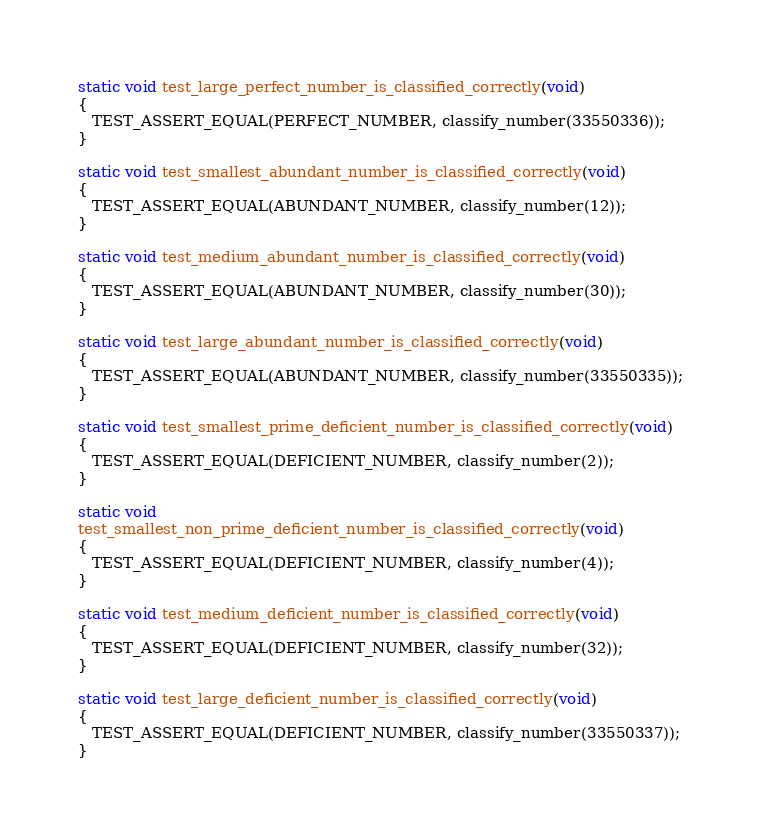<code> <loc_0><loc_0><loc_500><loc_500><_C_>static void test_large_perfect_number_is_classified_correctly(void)
{
   TEST_ASSERT_EQUAL(PERFECT_NUMBER, classify_number(33550336));
}

static void test_smallest_abundant_number_is_classified_correctly(void)
{
   TEST_ASSERT_EQUAL(ABUNDANT_NUMBER, classify_number(12));
}

static void test_medium_abundant_number_is_classified_correctly(void)
{
   TEST_ASSERT_EQUAL(ABUNDANT_NUMBER, classify_number(30));
}

static void test_large_abundant_number_is_classified_correctly(void)
{
   TEST_ASSERT_EQUAL(ABUNDANT_NUMBER, classify_number(33550335));
}

static void test_smallest_prime_deficient_number_is_classified_correctly(void)
{
   TEST_ASSERT_EQUAL(DEFICIENT_NUMBER, classify_number(2));
}

static void
test_smallest_non_prime_deficient_number_is_classified_correctly(void)
{
   TEST_ASSERT_EQUAL(DEFICIENT_NUMBER, classify_number(4));
}

static void test_medium_deficient_number_is_classified_correctly(void)
{
   TEST_ASSERT_EQUAL(DEFICIENT_NUMBER, classify_number(32));
}

static void test_large_deficient_number_is_classified_correctly(void)
{
   TEST_ASSERT_EQUAL(DEFICIENT_NUMBER, classify_number(33550337));
}
</code> 